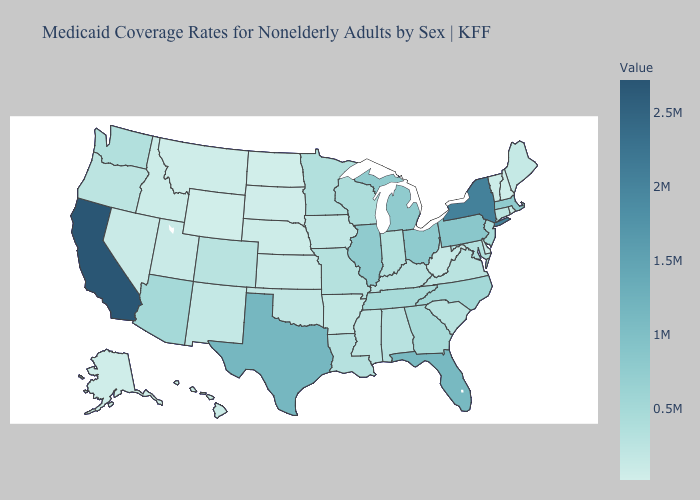Does Oklahoma have the lowest value in the South?
Write a very short answer. No. Does the map have missing data?
Keep it brief. No. Does Pennsylvania have the lowest value in the USA?
Be succinct. No. Does Ohio have the highest value in the MidWest?
Short answer required. Yes. Among the states that border West Virginia , which have the lowest value?
Keep it brief. Virginia. Does California have the highest value in the USA?
Write a very short answer. Yes. Does Minnesota have the highest value in the MidWest?
Answer briefly. No. Does Michigan have the lowest value in the MidWest?
Quick response, please. No. 